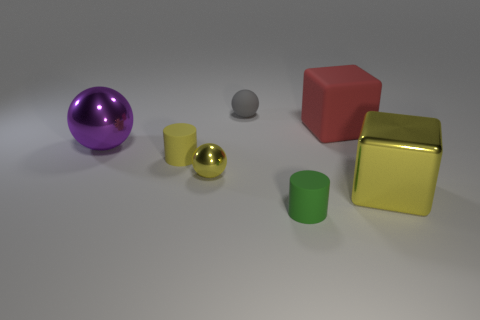Is the color of the cylinder that is behind the green matte thing the same as the small rubber cylinder that is in front of the large yellow metallic block? No, the color of the cylinder behind the green object is not the same as the small rubber cylinder in front of the yellow block. The cylinder in the back appears to have a grey hue, while the rubber cylinder up front displays a vivid yellow color similar to the metallic block, although the materials are different. 